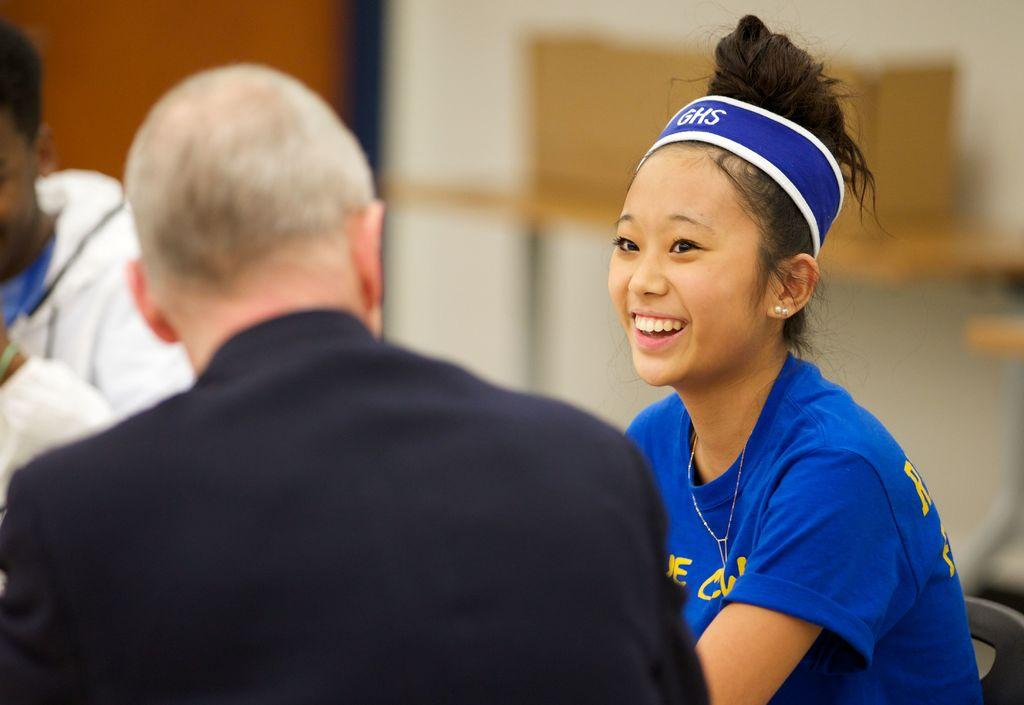What is the main subject of the image? The main subject of the image is a group of people. What are the people doing in the image? The people are sitting on chairs in the image. What can be seen in the background of the image? There is a table and a door in the background of the image. What type of button can be seen on the table in the image? There is no button present on the table in the image. How does the heat affect the people sitting in the image? The image does not provide any information about the temperature or heat, so we cannot determine how it affects the people. 